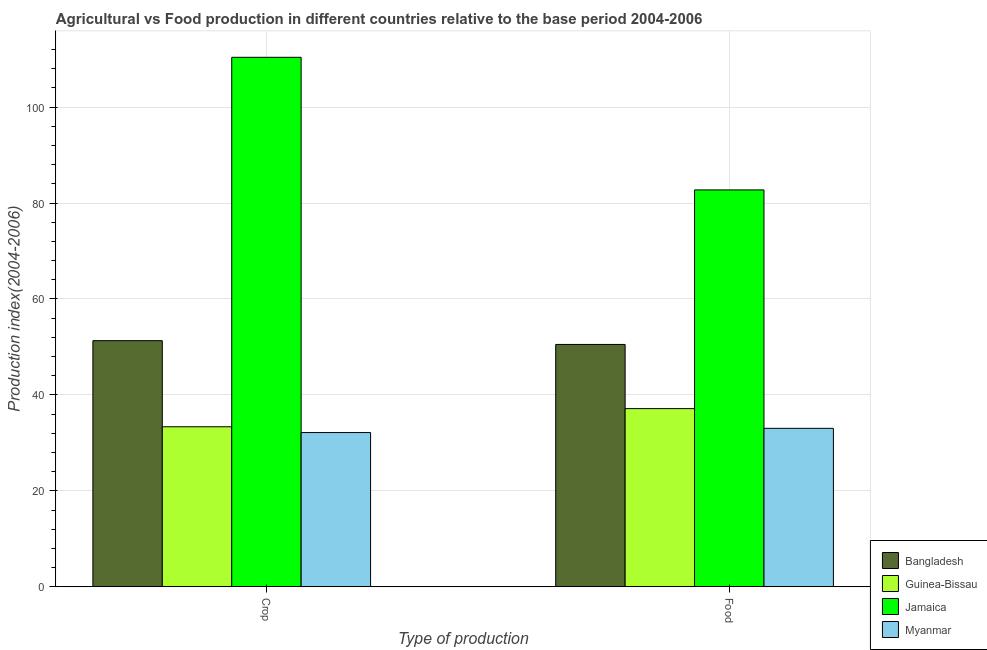How many groups of bars are there?
Your response must be concise. 2. Are the number of bars per tick equal to the number of legend labels?
Give a very brief answer. Yes. Are the number of bars on each tick of the X-axis equal?
Make the answer very short. Yes. How many bars are there on the 1st tick from the left?
Ensure brevity in your answer.  4. What is the label of the 2nd group of bars from the left?
Offer a very short reply. Food. What is the food production index in Bangladesh?
Provide a succinct answer. 50.52. Across all countries, what is the maximum food production index?
Provide a short and direct response. 82.74. Across all countries, what is the minimum food production index?
Your answer should be very brief. 33.03. In which country was the crop production index maximum?
Offer a very short reply. Jamaica. In which country was the food production index minimum?
Make the answer very short. Myanmar. What is the total food production index in the graph?
Keep it short and to the point. 203.43. What is the difference between the food production index in Jamaica and that in Guinea-Bissau?
Offer a terse response. 45.6. What is the difference between the food production index in Bangladesh and the crop production index in Jamaica?
Make the answer very short. -59.87. What is the average food production index per country?
Make the answer very short. 50.86. What is the difference between the food production index and crop production index in Myanmar?
Provide a short and direct response. 0.88. In how many countries, is the food production index greater than 4 ?
Your answer should be compact. 4. What is the ratio of the crop production index in Myanmar to that in Jamaica?
Your answer should be compact. 0.29. In how many countries, is the food production index greater than the average food production index taken over all countries?
Give a very brief answer. 1. What does the 3rd bar from the left in Food represents?
Provide a succinct answer. Jamaica. What does the 2nd bar from the right in Food represents?
Your response must be concise. Jamaica. Are all the bars in the graph horizontal?
Your response must be concise. No. How many countries are there in the graph?
Offer a very short reply. 4. What is the difference between two consecutive major ticks on the Y-axis?
Give a very brief answer. 20. Are the values on the major ticks of Y-axis written in scientific E-notation?
Ensure brevity in your answer.  No. Where does the legend appear in the graph?
Provide a short and direct response. Bottom right. What is the title of the graph?
Offer a terse response. Agricultural vs Food production in different countries relative to the base period 2004-2006. Does "Kosovo" appear as one of the legend labels in the graph?
Make the answer very short. No. What is the label or title of the X-axis?
Offer a terse response. Type of production. What is the label or title of the Y-axis?
Make the answer very short. Production index(2004-2006). What is the Production index(2004-2006) of Bangladesh in Crop?
Offer a very short reply. 51.31. What is the Production index(2004-2006) of Guinea-Bissau in Crop?
Provide a short and direct response. 33.36. What is the Production index(2004-2006) in Jamaica in Crop?
Keep it short and to the point. 110.39. What is the Production index(2004-2006) in Myanmar in Crop?
Offer a very short reply. 32.15. What is the Production index(2004-2006) of Bangladesh in Food?
Your answer should be compact. 50.52. What is the Production index(2004-2006) of Guinea-Bissau in Food?
Provide a short and direct response. 37.14. What is the Production index(2004-2006) in Jamaica in Food?
Offer a terse response. 82.74. What is the Production index(2004-2006) of Myanmar in Food?
Offer a very short reply. 33.03. Across all Type of production, what is the maximum Production index(2004-2006) in Bangladesh?
Make the answer very short. 51.31. Across all Type of production, what is the maximum Production index(2004-2006) in Guinea-Bissau?
Offer a terse response. 37.14. Across all Type of production, what is the maximum Production index(2004-2006) of Jamaica?
Offer a terse response. 110.39. Across all Type of production, what is the maximum Production index(2004-2006) of Myanmar?
Ensure brevity in your answer.  33.03. Across all Type of production, what is the minimum Production index(2004-2006) of Bangladesh?
Give a very brief answer. 50.52. Across all Type of production, what is the minimum Production index(2004-2006) in Guinea-Bissau?
Keep it short and to the point. 33.36. Across all Type of production, what is the minimum Production index(2004-2006) in Jamaica?
Your answer should be very brief. 82.74. Across all Type of production, what is the minimum Production index(2004-2006) in Myanmar?
Offer a terse response. 32.15. What is the total Production index(2004-2006) in Bangladesh in the graph?
Your response must be concise. 101.83. What is the total Production index(2004-2006) of Guinea-Bissau in the graph?
Keep it short and to the point. 70.5. What is the total Production index(2004-2006) of Jamaica in the graph?
Your answer should be compact. 193.13. What is the total Production index(2004-2006) of Myanmar in the graph?
Offer a very short reply. 65.18. What is the difference between the Production index(2004-2006) in Bangladesh in Crop and that in Food?
Make the answer very short. 0.79. What is the difference between the Production index(2004-2006) of Guinea-Bissau in Crop and that in Food?
Offer a very short reply. -3.78. What is the difference between the Production index(2004-2006) of Jamaica in Crop and that in Food?
Ensure brevity in your answer.  27.65. What is the difference between the Production index(2004-2006) of Myanmar in Crop and that in Food?
Provide a succinct answer. -0.88. What is the difference between the Production index(2004-2006) in Bangladesh in Crop and the Production index(2004-2006) in Guinea-Bissau in Food?
Your response must be concise. 14.17. What is the difference between the Production index(2004-2006) of Bangladesh in Crop and the Production index(2004-2006) of Jamaica in Food?
Provide a succinct answer. -31.43. What is the difference between the Production index(2004-2006) of Bangladesh in Crop and the Production index(2004-2006) of Myanmar in Food?
Give a very brief answer. 18.28. What is the difference between the Production index(2004-2006) of Guinea-Bissau in Crop and the Production index(2004-2006) of Jamaica in Food?
Your answer should be very brief. -49.38. What is the difference between the Production index(2004-2006) in Guinea-Bissau in Crop and the Production index(2004-2006) in Myanmar in Food?
Your answer should be very brief. 0.33. What is the difference between the Production index(2004-2006) in Jamaica in Crop and the Production index(2004-2006) in Myanmar in Food?
Provide a succinct answer. 77.36. What is the average Production index(2004-2006) in Bangladesh per Type of production?
Offer a terse response. 50.91. What is the average Production index(2004-2006) of Guinea-Bissau per Type of production?
Your answer should be compact. 35.25. What is the average Production index(2004-2006) of Jamaica per Type of production?
Your answer should be very brief. 96.56. What is the average Production index(2004-2006) of Myanmar per Type of production?
Keep it short and to the point. 32.59. What is the difference between the Production index(2004-2006) in Bangladesh and Production index(2004-2006) in Guinea-Bissau in Crop?
Offer a terse response. 17.95. What is the difference between the Production index(2004-2006) in Bangladesh and Production index(2004-2006) in Jamaica in Crop?
Offer a very short reply. -59.08. What is the difference between the Production index(2004-2006) in Bangladesh and Production index(2004-2006) in Myanmar in Crop?
Provide a succinct answer. 19.16. What is the difference between the Production index(2004-2006) of Guinea-Bissau and Production index(2004-2006) of Jamaica in Crop?
Offer a very short reply. -77.03. What is the difference between the Production index(2004-2006) in Guinea-Bissau and Production index(2004-2006) in Myanmar in Crop?
Ensure brevity in your answer.  1.21. What is the difference between the Production index(2004-2006) in Jamaica and Production index(2004-2006) in Myanmar in Crop?
Ensure brevity in your answer.  78.24. What is the difference between the Production index(2004-2006) of Bangladesh and Production index(2004-2006) of Guinea-Bissau in Food?
Your answer should be compact. 13.38. What is the difference between the Production index(2004-2006) of Bangladesh and Production index(2004-2006) of Jamaica in Food?
Your answer should be compact. -32.22. What is the difference between the Production index(2004-2006) of Bangladesh and Production index(2004-2006) of Myanmar in Food?
Your answer should be very brief. 17.49. What is the difference between the Production index(2004-2006) in Guinea-Bissau and Production index(2004-2006) in Jamaica in Food?
Ensure brevity in your answer.  -45.6. What is the difference between the Production index(2004-2006) in Guinea-Bissau and Production index(2004-2006) in Myanmar in Food?
Give a very brief answer. 4.11. What is the difference between the Production index(2004-2006) in Jamaica and Production index(2004-2006) in Myanmar in Food?
Your answer should be very brief. 49.71. What is the ratio of the Production index(2004-2006) of Bangladesh in Crop to that in Food?
Give a very brief answer. 1.02. What is the ratio of the Production index(2004-2006) of Guinea-Bissau in Crop to that in Food?
Ensure brevity in your answer.  0.9. What is the ratio of the Production index(2004-2006) in Jamaica in Crop to that in Food?
Give a very brief answer. 1.33. What is the ratio of the Production index(2004-2006) in Myanmar in Crop to that in Food?
Offer a terse response. 0.97. What is the difference between the highest and the second highest Production index(2004-2006) in Bangladesh?
Your answer should be compact. 0.79. What is the difference between the highest and the second highest Production index(2004-2006) in Guinea-Bissau?
Your response must be concise. 3.78. What is the difference between the highest and the second highest Production index(2004-2006) of Jamaica?
Keep it short and to the point. 27.65. What is the difference between the highest and the second highest Production index(2004-2006) in Myanmar?
Provide a succinct answer. 0.88. What is the difference between the highest and the lowest Production index(2004-2006) in Bangladesh?
Offer a very short reply. 0.79. What is the difference between the highest and the lowest Production index(2004-2006) of Guinea-Bissau?
Offer a very short reply. 3.78. What is the difference between the highest and the lowest Production index(2004-2006) in Jamaica?
Offer a terse response. 27.65. 